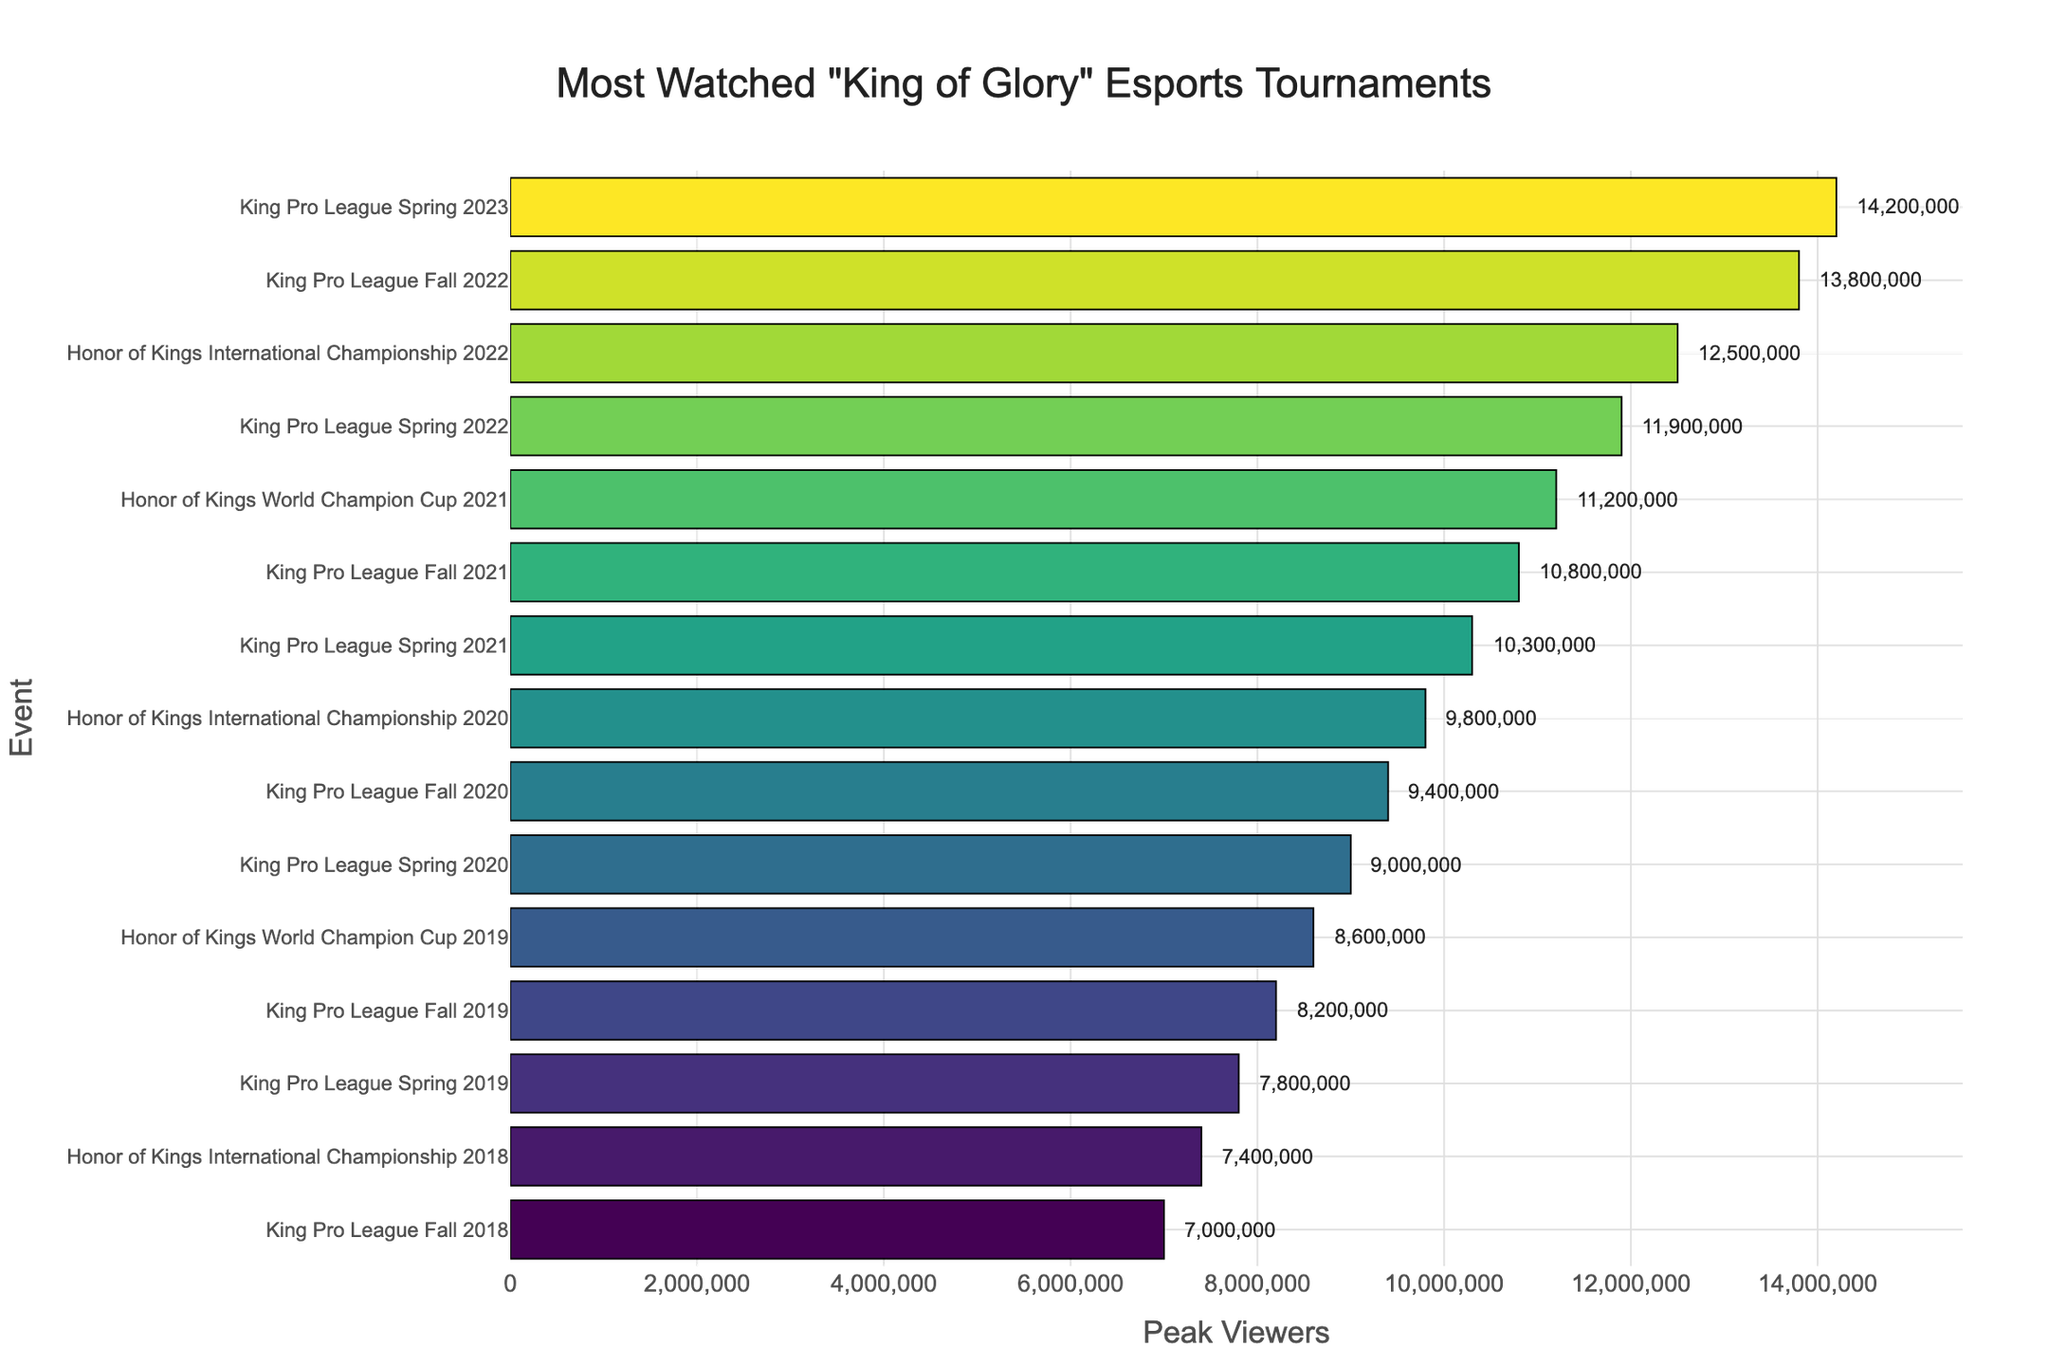What was the peak viewership of the King Pro League Spring 2023? The figure shows the number of peak viewers for each event. Looking at the bar labeled "King Pro League Spring 2023", we see it reaches 14,200,000 viewers.
Answer: 14,200,000 Which event had the lowest peak viewership? The smallest bar, representing the event with the lowest peak viewership, corresponds to the "King Pro League Fall 2018" with 7,000,000 viewers.
Answer: King Pro League Fall 2018 What is the difference in peak viewership between the King Pro League Spring 2023 and Honor of Kings International Championship 2022? The figure shows 14,200,000 peak viewers for King Pro League Spring 2023 and 12,500,000 for Honor of Kings International Championship 2022. The difference is 14,200,000 - 12,500,000 = 1,700,000.
Answer: 1,700,000 Which event had more peak viewers, King Pro League Fall 2022 or King Pro League Spring 2022? By comparing the bar lengths, King Pro League Fall 2022 had 13,800,000 peak viewers, which is more than King Pro League Spring 2022's 11,900,000.
Answer: King Pro League Fall 2022 How many events had peak viewership greater than 10,000,000? By counting the bars that extend past the 10,000,000 mark, there are six events: King Pro League Spring 2023, King Pro League Fall 2022, Honor of Kings International Championship 2022, King Pro League Spring 2022, Honor of Kings World Champion Cup 2021, and King Pro League Fall 2021.
Answer: 6 What is the average peak viewership of all the tournaments listed? Summing the peak viewers of all events (14,200,000 + 13,800,000 + 12,500,000 + 11,900,000 + 11,200,000 + 10,800,000 + 10,300,000 + 9,800,000 + 9,400,000 + 9,000,000 + 8,600,000 + 8,200,000 + 7,800,000 + 7,400,000 + 7,000,000) gives 156,900,000 total viewers. Dividing by 15 events, the average is 156,900,000 / 15 = 10,460,000.
Answer: 10,460,000 What is the combined peak viewership of the King Pro League events from 2021? Adding the peak viewers for King Pro League Spring 2021 (10,300,000), King Pro League Fall 2021 (10,800,000), and Honor of Kings World Champion Cup 2021 (11,200,000), the total is 10,300,000 + 10,800,000 + 11,200,000 = 32,300,000.
Answer: 32,300,000 Which event had the second-highest peak viewership? By examining the lengths of the bars, the second-longest bar corresponds to "King Pro League Fall 2022" with 13,800,000 viewers.
Answer: King Pro League Fall 2022 How many tournaments had peak viewership between 9,000,000 and 11,000,000? Counting the bars within the 9,000,000 to 11,000,000 range, we find four events: Honor of Kings International Championship 2020 (9,800,000), King Pro League Fall 2020 (9,400,000), King Pro League Spring 2020 (9,000,000), and Honor of Kings World Champion Cup 2021 (11,200,000).
Answer: 4 